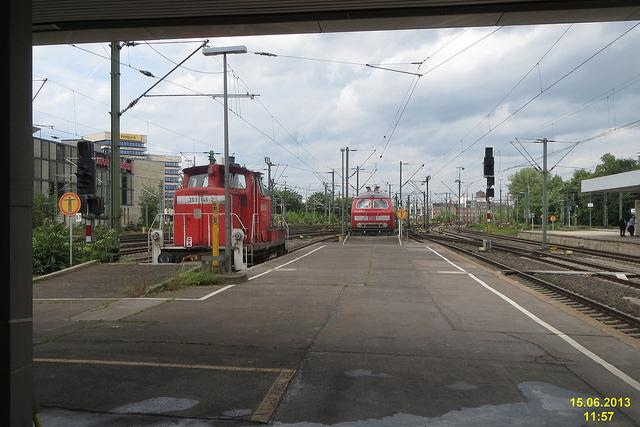How many years back the photograph was taken? Please explain your reasoning. eight. The date is seen in the bottom right hand corner so we can figure out how many years ago that was by doing some simple math. 